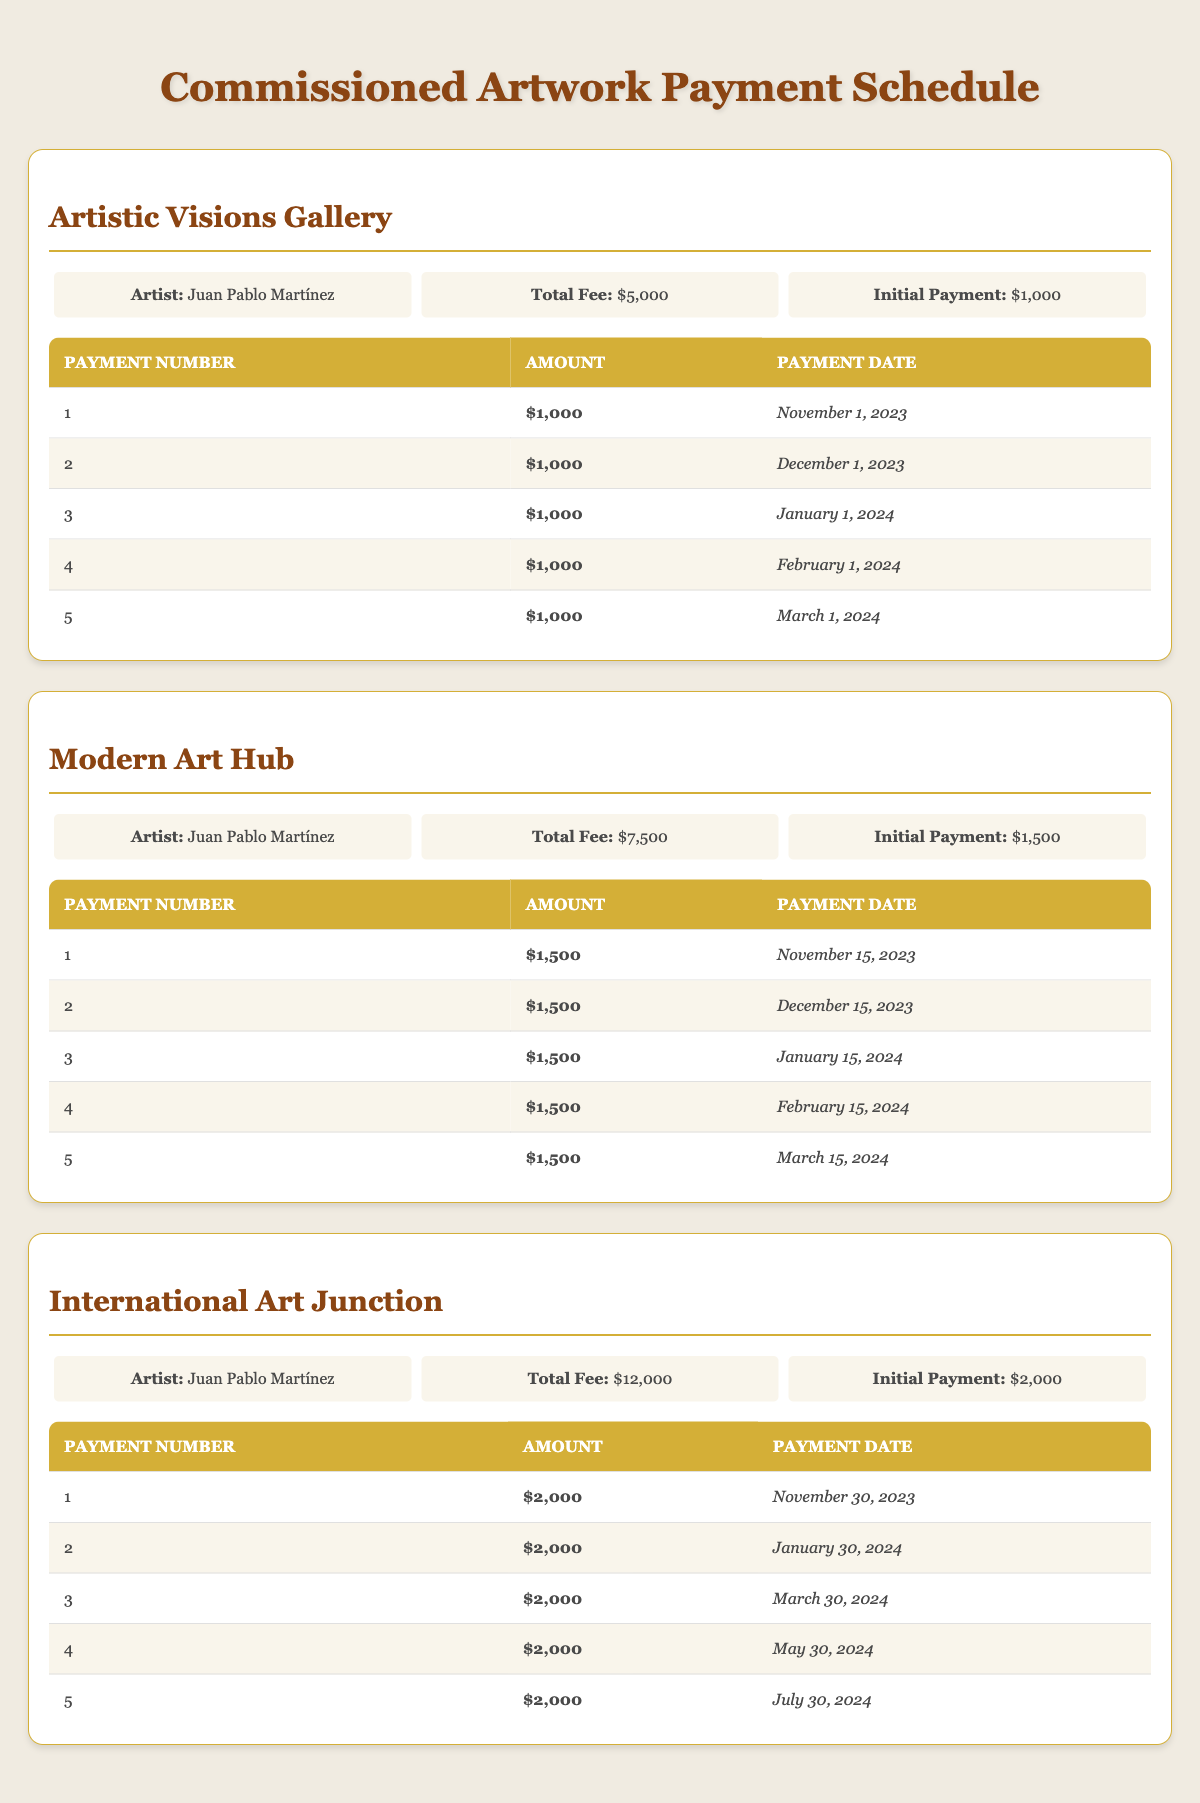What is the total fee for the commissioned artwork at Artistic Visions Gallery? The total fee is listed directly under Artistic Visions Gallery. It reads $5,000.
Answer: $5,000 How many payments are scheduled for the commissioned artwork at Modern Art Hub? There are a total of 5 payments listed under the payment schedule for Modern Art Hub.
Answer: 5 What is the amount of the last payment due at International Art Junction? The last payment, which is the 5th payment in the schedule for International Art Junction, is $2,000, as indicated in the table.
Answer: $2,000 Are the initial payments for the galleries the same? By looking at the initial payments for all galleries listed, Artistic Visions Gallery has an initial payment of $1,000, Modern Art Hub has $1,500, and International Art Junction has $2,000, which means the initial payments are not the same.
Answer: No What is the total amount of payments scheduled for the Modern Art Hub? Each of the 5 payments at Modern Art Hub is $1,500, so the total is calculated as 5 payments x $1,500 = $7,500.
Answer: $7,500 When is the second payment due at Artistic Visions Gallery? The schedule shows that the second payment is due on December 1, 2023.
Answer: December 1, 2023 Which gallery has the highest total fee? Comparing the total fees from the galleries, Artistic Visions Gallery has $5,000, Modern Art Hub has $7,500, and International Art Junction has $12,000. Thus, International Art Junction has the highest total fee.
Answer: International Art Junction What is the average amount of each payment at the International Art Junction? There are 5 payments each for $2,000, so to find the average amount, we divide the total payments by the number of payments: $12,000 / 5 = $2,400. Thus, the average amount per payment is $2,400.
Answer: $2,400 How many payments are made after January 1st at Artistic Visions Gallery? Payments are scheduled for February 1, 2024, and March 1, 2024, which are 2 payments made after January 1st.
Answer: 2 